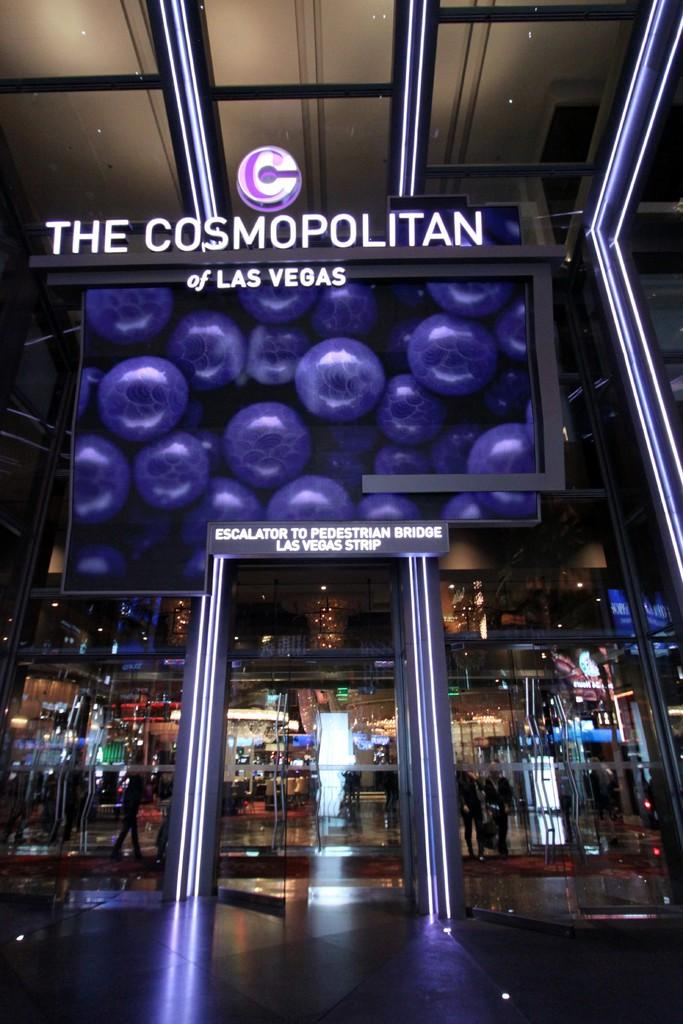Provide a one-sentence caption for the provided image. Entrance for The Cosmopolitan of Las Vegas in purple. 